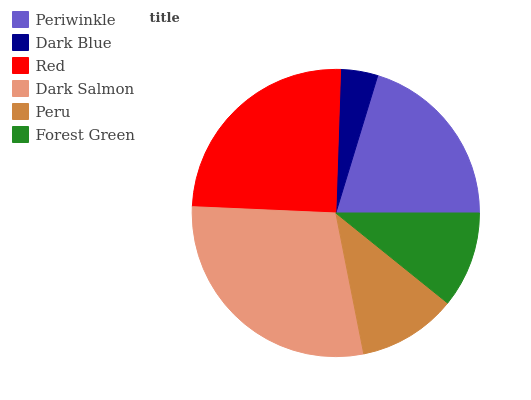Is Dark Blue the minimum?
Answer yes or no. Yes. Is Dark Salmon the maximum?
Answer yes or no. Yes. Is Red the minimum?
Answer yes or no. No. Is Red the maximum?
Answer yes or no. No. Is Red greater than Dark Blue?
Answer yes or no. Yes. Is Dark Blue less than Red?
Answer yes or no. Yes. Is Dark Blue greater than Red?
Answer yes or no. No. Is Red less than Dark Blue?
Answer yes or no. No. Is Periwinkle the high median?
Answer yes or no. Yes. Is Peru the low median?
Answer yes or no. Yes. Is Dark Salmon the high median?
Answer yes or no. No. Is Forest Green the low median?
Answer yes or no. No. 